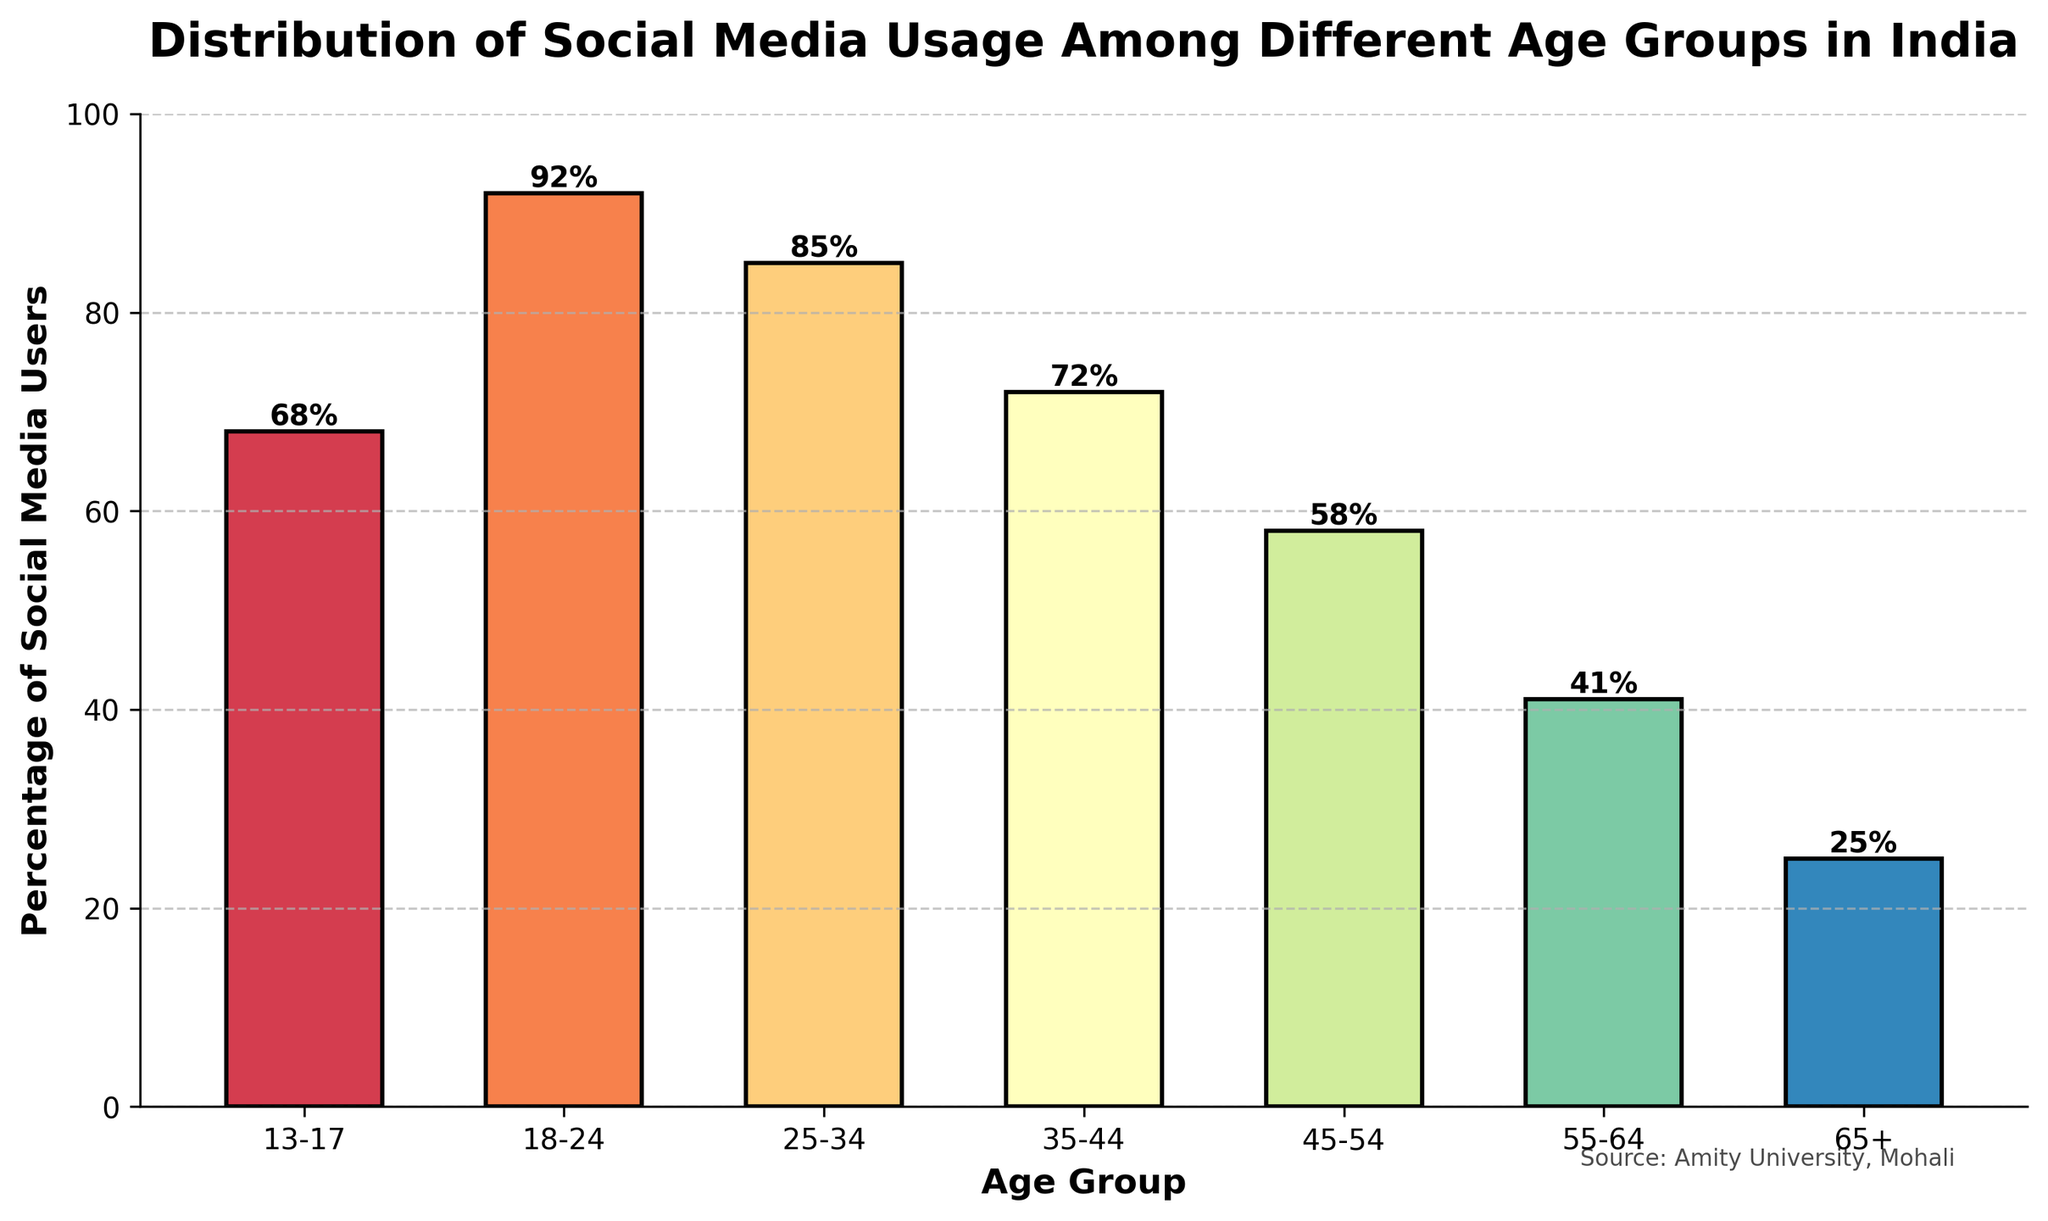Which age group has the highest percentage of social media users? The bar representing the age group "18-24" is the tallest, indicating it has the highest percentage of users with 92%.
Answer: 18-24 What is the percentage difference in social media usage between the 25-34 and 45-54 age groups? The percentage for the 25-34 age group is 85%, and for the 45-54 age group, it is 58%. The difference is 85% - 58% = 27%.
Answer: 27% Which age groups have more than 70% of social media users? By examining the height of the bars, the age groups "13-17", "18-24", "25-34", and "35-44" have bars reaching above the 70% mark.
Answer: 13-17, 18-24, 25-34, 35-44 How many age groups have a percentage of social media users below 50%? The percentage of social media users is below 50% for the age groups "55-64" and "65+", as indicated by their shorter bars. That makes two groups.
Answer: 2 What is the percentage sum of the social media usage for the age groups 13-17 and 65+? The percentages for the 13-17 and 65+ age groups are 68% and 25%, respectively. Adding them together: 68% + 25% = 93%.
Answer: 93% Is the percentage of social media users in the age group 35-44 greater than that in the 55-64 age group? The height of the bar for the 35-44 age group is taller than that of the 55-64 age group, indicating that the percentage (72%) is greater than 41%.
Answer: Yes Which age group has the second lowest percentage of social media users? By comparing the heights of the bars, the second shortest bar corresponds to the age group "55-64" with 41%, right after "65+".
Answer: 55-64 What is the average percentage of social media users for the age groups 13-17, 18-24, and 25-34? The percentages are 68%, 92%, and 85%. Summing them: 68 + 92 + 85 = 245. Average = 245/3 ≈ 81.67%.
Answer: 81.67% Between which two consecutive age groups is the greatest drop in social media usage observed? Observing the heights of the bars, the greatest drop occurs between "18-24" (92%) and "25-34" (85%), a difference of 7%.
Answer: 18-24 and 25-34 